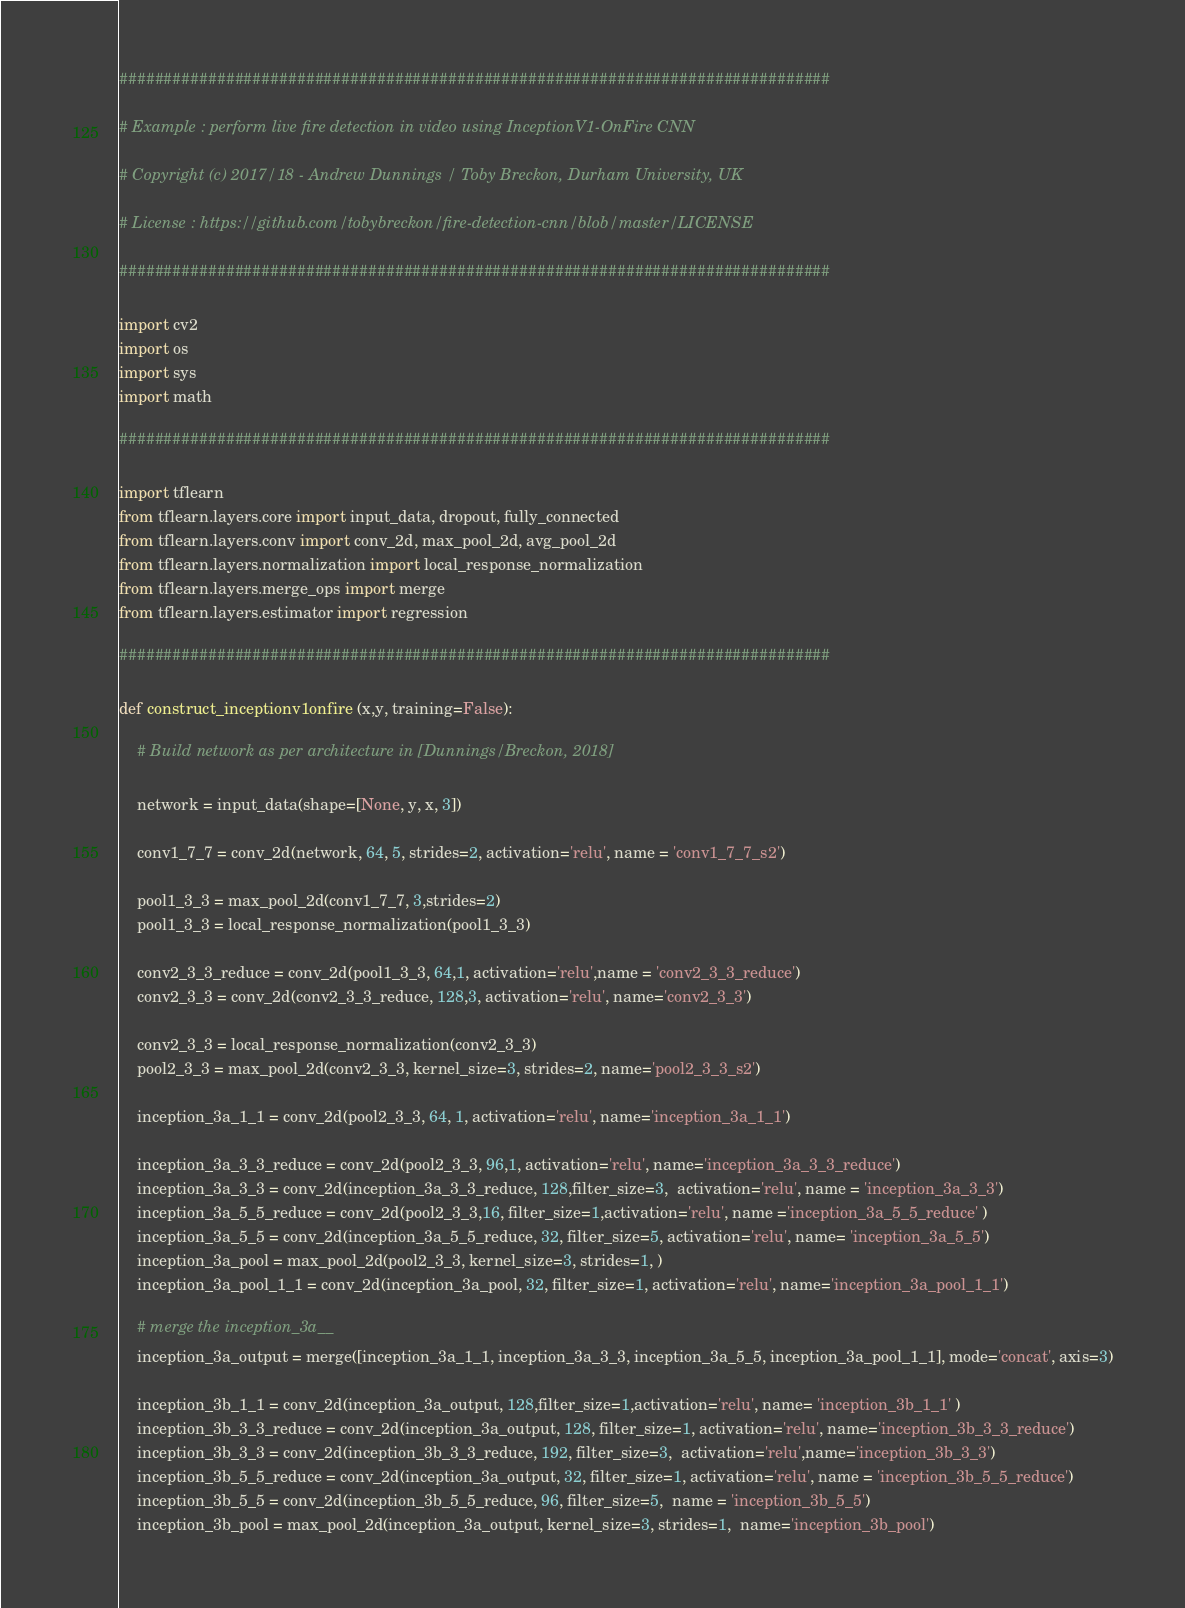<code> <loc_0><loc_0><loc_500><loc_500><_Python_>################################################################################

# Example : perform live fire detection in video using InceptionV1-OnFire CNN

# Copyright (c) 2017/18 - Andrew Dunnings / Toby Breckon, Durham University, UK

# License : https://github.com/tobybreckon/fire-detection-cnn/blob/master/LICENSE

################################################################################

import cv2
import os
import sys
import math

################################################################################

import tflearn
from tflearn.layers.core import input_data, dropout, fully_connected
from tflearn.layers.conv import conv_2d, max_pool_2d, avg_pool_2d
from tflearn.layers.normalization import local_response_normalization
from tflearn.layers.merge_ops import merge
from tflearn.layers.estimator import regression

################################################################################

def construct_inceptionv1onfire (x,y, training=False):

    # Build network as per architecture in [Dunnings/Breckon, 2018]

    network = input_data(shape=[None, y, x, 3])

    conv1_7_7 = conv_2d(network, 64, 5, strides=2, activation='relu', name = 'conv1_7_7_s2')

    pool1_3_3 = max_pool_2d(conv1_7_7, 3,strides=2)
    pool1_3_3 = local_response_normalization(pool1_3_3)

    conv2_3_3_reduce = conv_2d(pool1_3_3, 64,1, activation='relu',name = 'conv2_3_3_reduce')
    conv2_3_3 = conv_2d(conv2_3_3_reduce, 128,3, activation='relu', name='conv2_3_3')

    conv2_3_3 = local_response_normalization(conv2_3_3)
    pool2_3_3 = max_pool_2d(conv2_3_3, kernel_size=3, strides=2, name='pool2_3_3_s2')

    inception_3a_1_1 = conv_2d(pool2_3_3, 64, 1, activation='relu', name='inception_3a_1_1')

    inception_3a_3_3_reduce = conv_2d(pool2_3_3, 96,1, activation='relu', name='inception_3a_3_3_reduce')
    inception_3a_3_3 = conv_2d(inception_3a_3_3_reduce, 128,filter_size=3,  activation='relu', name = 'inception_3a_3_3')
    inception_3a_5_5_reduce = conv_2d(pool2_3_3,16, filter_size=1,activation='relu', name ='inception_3a_5_5_reduce' )
    inception_3a_5_5 = conv_2d(inception_3a_5_5_reduce, 32, filter_size=5, activation='relu', name= 'inception_3a_5_5')
    inception_3a_pool = max_pool_2d(pool2_3_3, kernel_size=3, strides=1, )
    inception_3a_pool_1_1 = conv_2d(inception_3a_pool, 32, filter_size=1, activation='relu', name='inception_3a_pool_1_1')

    # merge the inception_3a__
    inception_3a_output = merge([inception_3a_1_1, inception_3a_3_3, inception_3a_5_5, inception_3a_pool_1_1], mode='concat', axis=3)

    inception_3b_1_1 = conv_2d(inception_3a_output, 128,filter_size=1,activation='relu', name= 'inception_3b_1_1' )
    inception_3b_3_3_reduce = conv_2d(inception_3a_output, 128, filter_size=1, activation='relu', name='inception_3b_3_3_reduce')
    inception_3b_3_3 = conv_2d(inception_3b_3_3_reduce, 192, filter_size=3,  activation='relu',name='inception_3b_3_3')
    inception_3b_5_5_reduce = conv_2d(inception_3a_output, 32, filter_size=1, activation='relu', name = 'inception_3b_5_5_reduce')
    inception_3b_5_5 = conv_2d(inception_3b_5_5_reduce, 96, filter_size=5,  name = 'inception_3b_5_5')
    inception_3b_pool = max_pool_2d(inception_3a_output, kernel_size=3, strides=1,  name='inception_3b_pool')</code> 